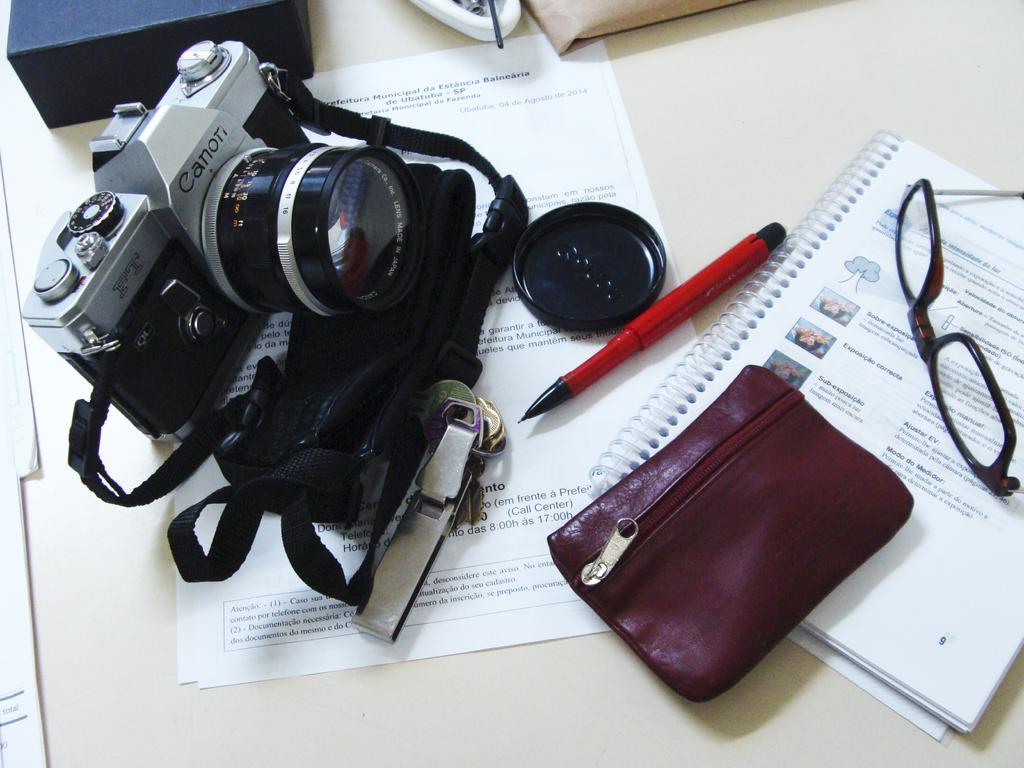What is the main object in the image? There is a camera in the image. What other objects can be seen in the image? There is a pen, spectacles, papers, a book, and a wallet visible in the image. Where are these objects placed in the image? All these objects are placed on a surface. What type of error can be seen in the image? There is no error present in the image; it features various objects placed on a surface. What type of feast is being prepared in the image? There is no feast being prepared in the image; it features a camera, pen, spectacles, papers, book, and wallet placed on a surface. 